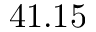<formula> <loc_0><loc_0><loc_500><loc_500>4 1 . 1 5</formula> 